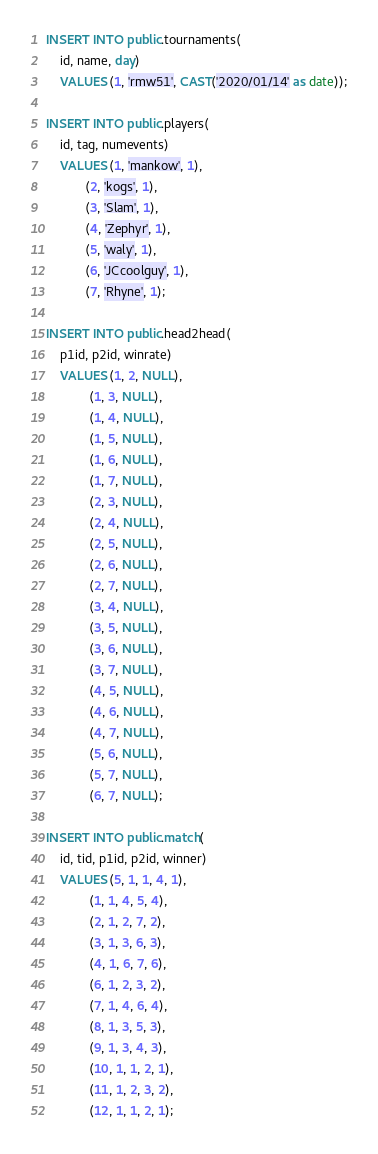Convert code to text. <code><loc_0><loc_0><loc_500><loc_500><_SQL_>INSERT INTO public.tournaments(
	id, name, day)
	VALUES (1, 'rmw51', CAST('2020/01/14' as date));

INSERT INTO public.players(
	id, tag, numevents)
	VALUES (1, 'mankow', 1),
		   (2, 'kogs', 1),
		   (3, 'Slam', 1),
		   (4, 'Zephyr', 1),
		   (5, 'waly', 1),
		   (6, 'JCcoolguy', 1),
		   (7, 'Rhyne', 1);

INSERT INTO public.head2head(
	p1id, p2id, winrate)
	VALUES (1, 2, NULL),
			(1, 3, NULL),
			(1, 4, NULL),
			(1, 5, NULL),
			(1, 6, NULL),
			(1, 7, NULL),
			(2, 3, NULL),
			(2, 4, NULL),
			(2, 5, NULL),
			(2, 6, NULL),
			(2, 7, NULL),
			(3, 4, NULL),
			(3, 5, NULL),
			(3, 6, NULL),
			(3, 7, NULL),
			(4, 5, NULL),
			(4, 6, NULL),
			(4, 7, NULL),
			(5, 6, NULL),
			(5, 7, NULL),
			(6, 7, NULL);

INSERT INTO public.match(
	id, tid, p1id, p2id, winner)
	VALUES (5, 1, 1, 4, 1),
			(1, 1, 4, 5, 4),
			(2, 1, 2, 7, 2),
			(3, 1, 3, 6, 3),
			(4, 1, 6, 7, 6),
			(6, 1, 2, 3, 2),
			(7, 1, 4, 6, 4),
			(8, 1, 3, 5, 3),
			(9, 1, 3, 4, 3),
			(10, 1, 1, 2, 1),
			(11, 1, 2, 3, 2),
			(12, 1, 1, 2, 1);</code> 